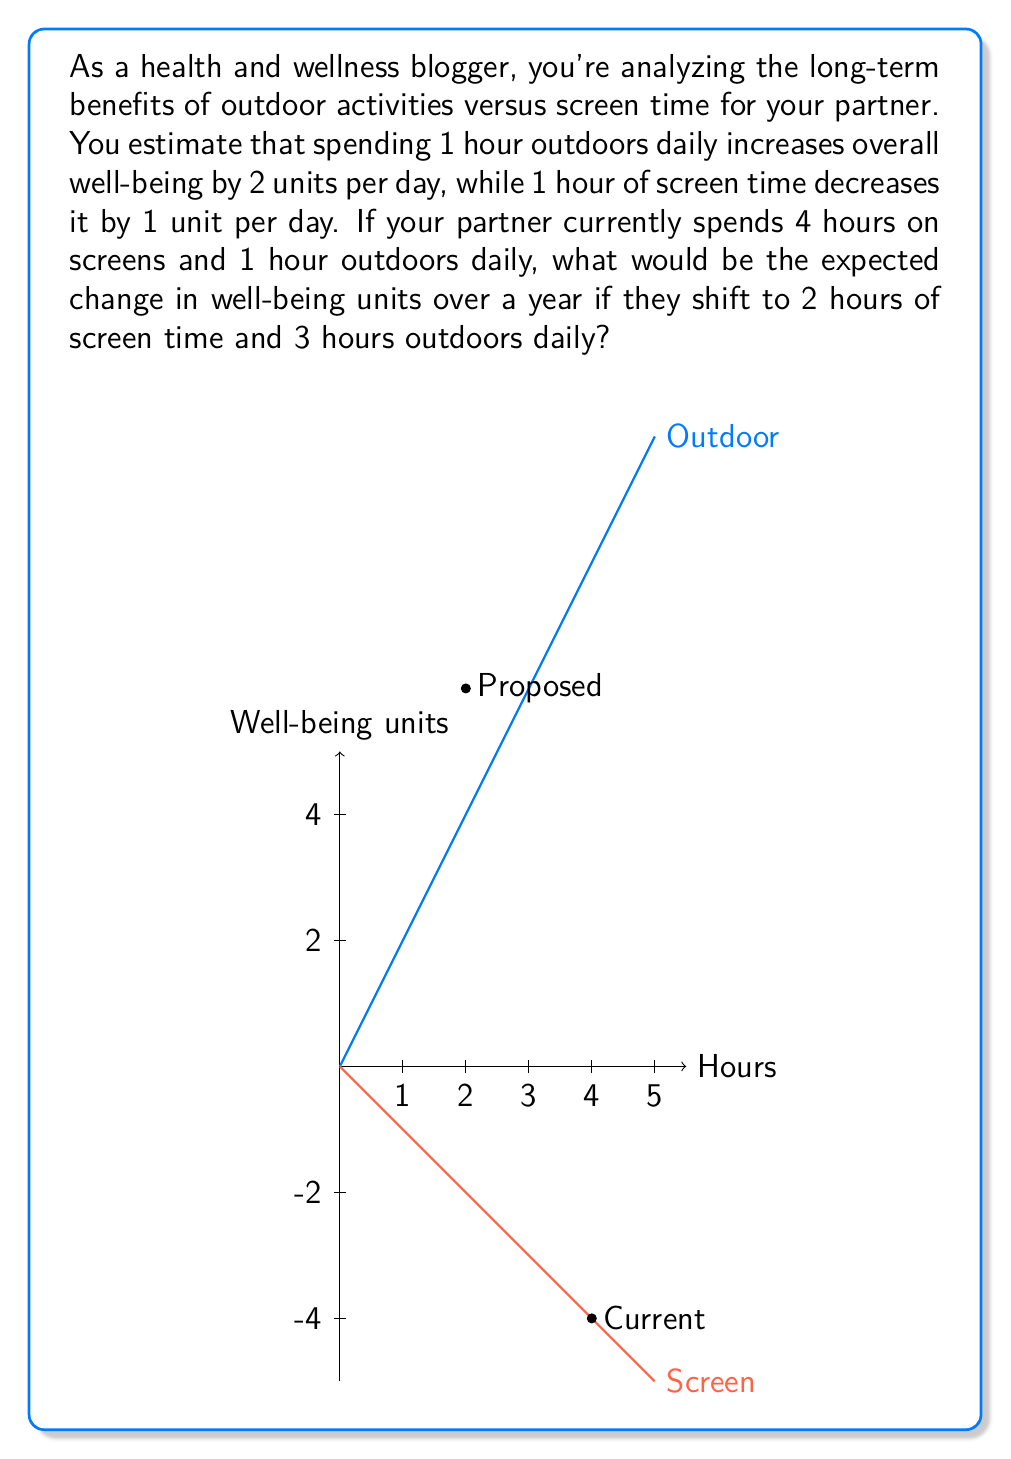Solve this math problem. Let's approach this step-by-step:

1) First, let's calculate the current daily impact:
   - Screen time: $4 \text{ hours} \times (-1 \text{ unit/hour}) = -4 \text{ units}$
   - Outdoor time: $1 \text{ hour} \times 2 \text{ units/hour} = 2 \text{ units}$
   - Net daily impact: $-4 + 2 = -2 \text{ units}$

2) Now, let's calculate the proposed daily impact:
   - Screen time: $2 \text{ hours} \times (-1 \text{ unit/hour}) = -2 \text{ units}$
   - Outdoor time: $3 \text{ hours} \times 2 \text{ units/hour} = 6 \text{ units}$
   - Net daily impact: $-2 + 6 = 4 \text{ units}$

3) The change in daily impact is:
   $4 \text{ units} - (-2 \text{ units}) = 6 \text{ units}$

4) To calculate the change over a year, we multiply by 365 days:
   $6 \text{ units/day} \times 365 \text{ days} = 2190 \text{ units}$

Therefore, the expected change in well-being units over a year with the proposed shift in time allocation is an increase of 2190 units.
Answer: 2190 units 